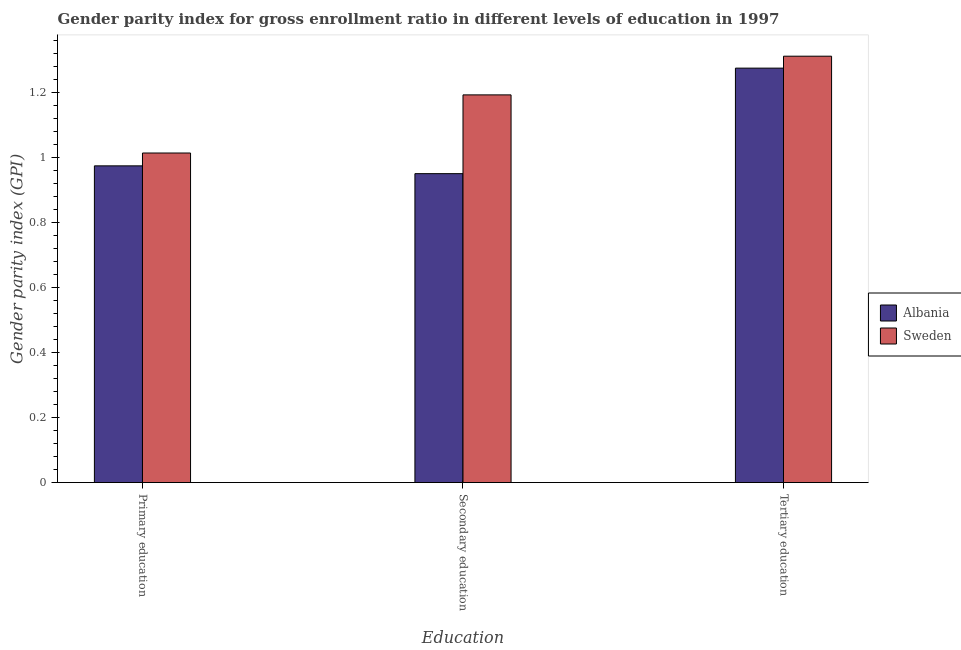How many different coloured bars are there?
Provide a succinct answer. 2. Are the number of bars per tick equal to the number of legend labels?
Give a very brief answer. Yes. Are the number of bars on each tick of the X-axis equal?
Provide a succinct answer. Yes. How many bars are there on the 1st tick from the left?
Your answer should be compact. 2. How many bars are there on the 2nd tick from the right?
Provide a short and direct response. 2. What is the label of the 3rd group of bars from the left?
Your answer should be compact. Tertiary education. What is the gender parity index in tertiary education in Albania?
Give a very brief answer. 1.28. Across all countries, what is the maximum gender parity index in primary education?
Make the answer very short. 1.01. Across all countries, what is the minimum gender parity index in primary education?
Your response must be concise. 0.98. In which country was the gender parity index in tertiary education minimum?
Keep it short and to the point. Albania. What is the total gender parity index in primary education in the graph?
Give a very brief answer. 1.99. What is the difference between the gender parity index in primary education in Sweden and that in Albania?
Offer a terse response. 0.04. What is the difference between the gender parity index in secondary education in Albania and the gender parity index in primary education in Sweden?
Your response must be concise. -0.06. What is the average gender parity index in tertiary education per country?
Provide a succinct answer. 1.29. What is the difference between the gender parity index in primary education and gender parity index in tertiary education in Albania?
Provide a short and direct response. -0.3. In how many countries, is the gender parity index in tertiary education greater than 0.68 ?
Offer a very short reply. 2. What is the ratio of the gender parity index in secondary education in Albania to that in Sweden?
Offer a very short reply. 0.8. Is the difference between the gender parity index in secondary education in Sweden and Albania greater than the difference between the gender parity index in tertiary education in Sweden and Albania?
Provide a short and direct response. Yes. What is the difference between the highest and the second highest gender parity index in primary education?
Offer a terse response. 0.04. What is the difference between the highest and the lowest gender parity index in secondary education?
Give a very brief answer. 0.24. What does the 1st bar from the left in Primary education represents?
Provide a succinct answer. Albania. What does the 1st bar from the right in Secondary education represents?
Make the answer very short. Sweden. Is it the case that in every country, the sum of the gender parity index in primary education and gender parity index in secondary education is greater than the gender parity index in tertiary education?
Your answer should be very brief. Yes. How many bars are there?
Give a very brief answer. 6. Does the graph contain any zero values?
Your answer should be compact. No. How many legend labels are there?
Offer a very short reply. 2. What is the title of the graph?
Make the answer very short. Gender parity index for gross enrollment ratio in different levels of education in 1997. Does "Cameroon" appear as one of the legend labels in the graph?
Your response must be concise. No. What is the label or title of the X-axis?
Your response must be concise. Education. What is the label or title of the Y-axis?
Your answer should be very brief. Gender parity index (GPI). What is the Gender parity index (GPI) in Albania in Primary education?
Give a very brief answer. 0.98. What is the Gender parity index (GPI) in Sweden in Primary education?
Provide a succinct answer. 1.01. What is the Gender parity index (GPI) of Albania in Secondary education?
Your answer should be very brief. 0.95. What is the Gender parity index (GPI) in Sweden in Secondary education?
Make the answer very short. 1.19. What is the Gender parity index (GPI) in Albania in Tertiary education?
Provide a short and direct response. 1.28. What is the Gender parity index (GPI) in Sweden in Tertiary education?
Ensure brevity in your answer.  1.31. Across all Education, what is the maximum Gender parity index (GPI) in Albania?
Ensure brevity in your answer.  1.28. Across all Education, what is the maximum Gender parity index (GPI) in Sweden?
Your answer should be compact. 1.31. Across all Education, what is the minimum Gender parity index (GPI) in Albania?
Provide a succinct answer. 0.95. Across all Education, what is the minimum Gender parity index (GPI) in Sweden?
Your answer should be compact. 1.01. What is the total Gender parity index (GPI) in Albania in the graph?
Your response must be concise. 3.2. What is the total Gender parity index (GPI) of Sweden in the graph?
Provide a short and direct response. 3.52. What is the difference between the Gender parity index (GPI) in Albania in Primary education and that in Secondary education?
Ensure brevity in your answer.  0.02. What is the difference between the Gender parity index (GPI) in Sweden in Primary education and that in Secondary education?
Offer a terse response. -0.18. What is the difference between the Gender parity index (GPI) of Albania in Primary education and that in Tertiary education?
Provide a short and direct response. -0.3. What is the difference between the Gender parity index (GPI) of Sweden in Primary education and that in Tertiary education?
Give a very brief answer. -0.3. What is the difference between the Gender parity index (GPI) in Albania in Secondary education and that in Tertiary education?
Offer a very short reply. -0.32. What is the difference between the Gender parity index (GPI) of Sweden in Secondary education and that in Tertiary education?
Provide a short and direct response. -0.12. What is the difference between the Gender parity index (GPI) of Albania in Primary education and the Gender parity index (GPI) of Sweden in Secondary education?
Provide a short and direct response. -0.22. What is the difference between the Gender parity index (GPI) in Albania in Primary education and the Gender parity index (GPI) in Sweden in Tertiary education?
Your answer should be very brief. -0.34. What is the difference between the Gender parity index (GPI) in Albania in Secondary education and the Gender parity index (GPI) in Sweden in Tertiary education?
Your answer should be compact. -0.36. What is the average Gender parity index (GPI) of Albania per Education?
Your answer should be very brief. 1.07. What is the average Gender parity index (GPI) in Sweden per Education?
Offer a terse response. 1.17. What is the difference between the Gender parity index (GPI) in Albania and Gender parity index (GPI) in Sweden in Primary education?
Your response must be concise. -0.04. What is the difference between the Gender parity index (GPI) in Albania and Gender parity index (GPI) in Sweden in Secondary education?
Give a very brief answer. -0.24. What is the difference between the Gender parity index (GPI) of Albania and Gender parity index (GPI) of Sweden in Tertiary education?
Make the answer very short. -0.04. What is the ratio of the Gender parity index (GPI) in Albania in Primary education to that in Secondary education?
Your response must be concise. 1.03. What is the ratio of the Gender parity index (GPI) of Sweden in Primary education to that in Secondary education?
Offer a very short reply. 0.85. What is the ratio of the Gender parity index (GPI) of Albania in Primary education to that in Tertiary education?
Provide a succinct answer. 0.76. What is the ratio of the Gender parity index (GPI) in Sweden in Primary education to that in Tertiary education?
Provide a short and direct response. 0.77. What is the ratio of the Gender parity index (GPI) in Albania in Secondary education to that in Tertiary education?
Provide a succinct answer. 0.75. What is the ratio of the Gender parity index (GPI) in Sweden in Secondary education to that in Tertiary education?
Provide a succinct answer. 0.91. What is the difference between the highest and the second highest Gender parity index (GPI) in Albania?
Ensure brevity in your answer.  0.3. What is the difference between the highest and the second highest Gender parity index (GPI) in Sweden?
Your answer should be very brief. 0.12. What is the difference between the highest and the lowest Gender parity index (GPI) of Albania?
Your answer should be compact. 0.32. What is the difference between the highest and the lowest Gender parity index (GPI) of Sweden?
Offer a very short reply. 0.3. 